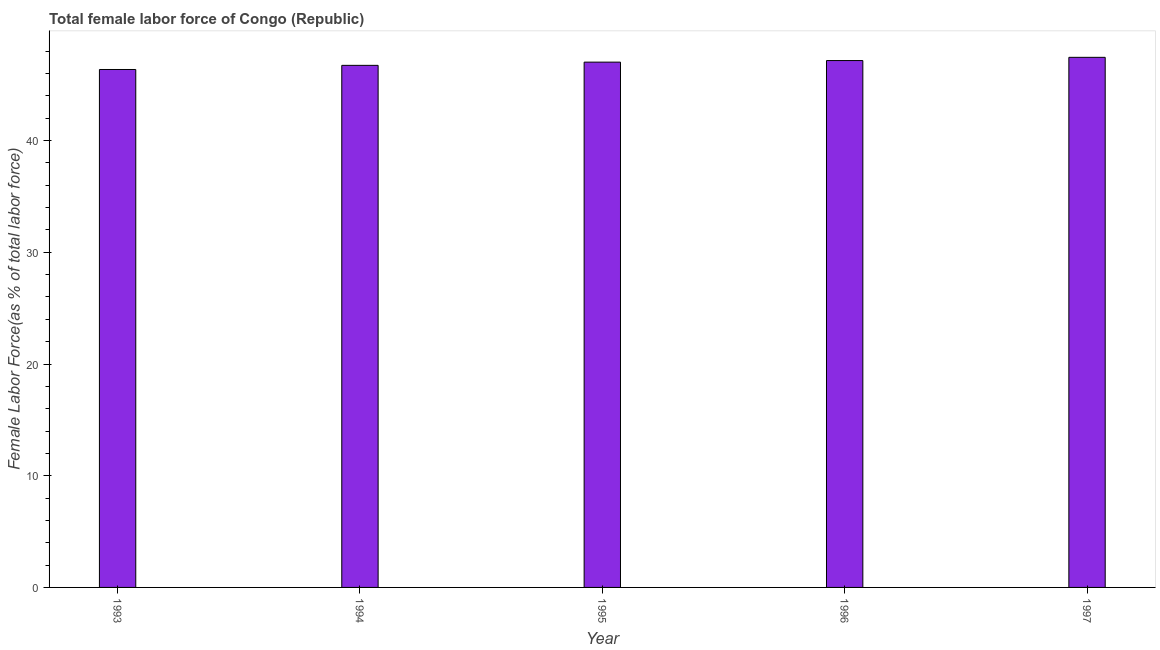Does the graph contain any zero values?
Offer a very short reply. No. What is the title of the graph?
Provide a succinct answer. Total female labor force of Congo (Republic). What is the label or title of the Y-axis?
Make the answer very short. Female Labor Force(as % of total labor force). What is the total female labor force in 1996?
Your answer should be very brief. 47.16. Across all years, what is the maximum total female labor force?
Offer a very short reply. 47.45. Across all years, what is the minimum total female labor force?
Your answer should be very brief. 46.36. In which year was the total female labor force maximum?
Give a very brief answer. 1997. In which year was the total female labor force minimum?
Ensure brevity in your answer.  1993. What is the sum of the total female labor force?
Your answer should be compact. 234.73. What is the difference between the total female labor force in 1996 and 1997?
Give a very brief answer. -0.29. What is the average total female labor force per year?
Provide a succinct answer. 46.95. What is the median total female labor force?
Your answer should be very brief. 47.02. In how many years, is the total female labor force greater than 4 %?
Ensure brevity in your answer.  5. Do a majority of the years between 1997 and 1996 (inclusive) have total female labor force greater than 28 %?
Provide a short and direct response. No. What is the ratio of the total female labor force in 1995 to that in 1997?
Provide a succinct answer. 0.99. Is the total female labor force in 1995 less than that in 1997?
Offer a very short reply. Yes. What is the difference between the highest and the second highest total female labor force?
Give a very brief answer. 0.29. What is the difference between the highest and the lowest total female labor force?
Ensure brevity in your answer.  1.09. In how many years, is the total female labor force greater than the average total female labor force taken over all years?
Your answer should be very brief. 3. How many years are there in the graph?
Your answer should be compact. 5. What is the Female Labor Force(as % of total labor force) in 1993?
Ensure brevity in your answer.  46.36. What is the Female Labor Force(as % of total labor force) in 1994?
Your answer should be compact. 46.73. What is the Female Labor Force(as % of total labor force) of 1995?
Offer a very short reply. 47.02. What is the Female Labor Force(as % of total labor force) in 1996?
Your answer should be very brief. 47.16. What is the Female Labor Force(as % of total labor force) in 1997?
Make the answer very short. 47.45. What is the difference between the Female Labor Force(as % of total labor force) in 1993 and 1994?
Offer a terse response. -0.37. What is the difference between the Female Labor Force(as % of total labor force) in 1993 and 1995?
Keep it short and to the point. -0.66. What is the difference between the Female Labor Force(as % of total labor force) in 1993 and 1996?
Offer a very short reply. -0.8. What is the difference between the Female Labor Force(as % of total labor force) in 1993 and 1997?
Provide a succinct answer. -1.09. What is the difference between the Female Labor Force(as % of total labor force) in 1994 and 1995?
Offer a very short reply. -0.29. What is the difference between the Female Labor Force(as % of total labor force) in 1994 and 1996?
Make the answer very short. -0.43. What is the difference between the Female Labor Force(as % of total labor force) in 1994 and 1997?
Your answer should be compact. -0.72. What is the difference between the Female Labor Force(as % of total labor force) in 1995 and 1996?
Offer a very short reply. -0.14. What is the difference between the Female Labor Force(as % of total labor force) in 1995 and 1997?
Make the answer very short. -0.43. What is the difference between the Female Labor Force(as % of total labor force) in 1996 and 1997?
Provide a short and direct response. -0.29. What is the ratio of the Female Labor Force(as % of total labor force) in 1993 to that in 1995?
Ensure brevity in your answer.  0.99. What is the ratio of the Female Labor Force(as % of total labor force) in 1993 to that in 1996?
Provide a short and direct response. 0.98. What is the ratio of the Female Labor Force(as % of total labor force) in 1995 to that in 1997?
Provide a short and direct response. 0.99. 